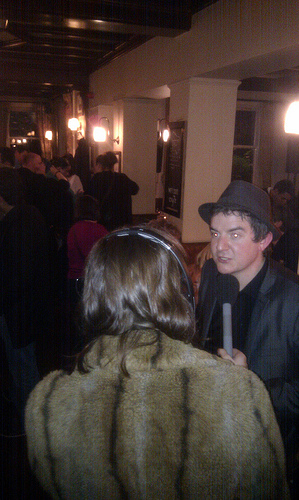<image>
Is there a man under the candle? No. The man is not positioned under the candle. The vertical relationship between these objects is different. 